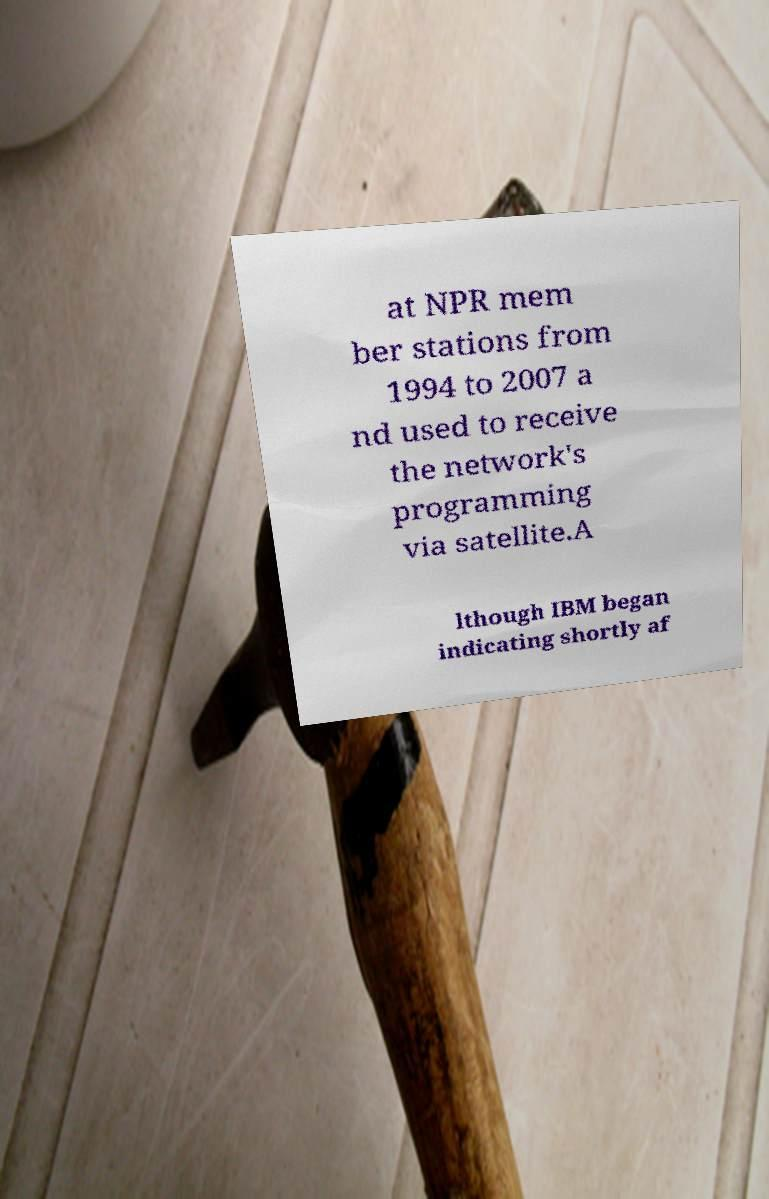There's text embedded in this image that I need extracted. Can you transcribe it verbatim? at NPR mem ber stations from 1994 to 2007 a nd used to receive the network's programming via satellite.A lthough IBM began indicating shortly af 